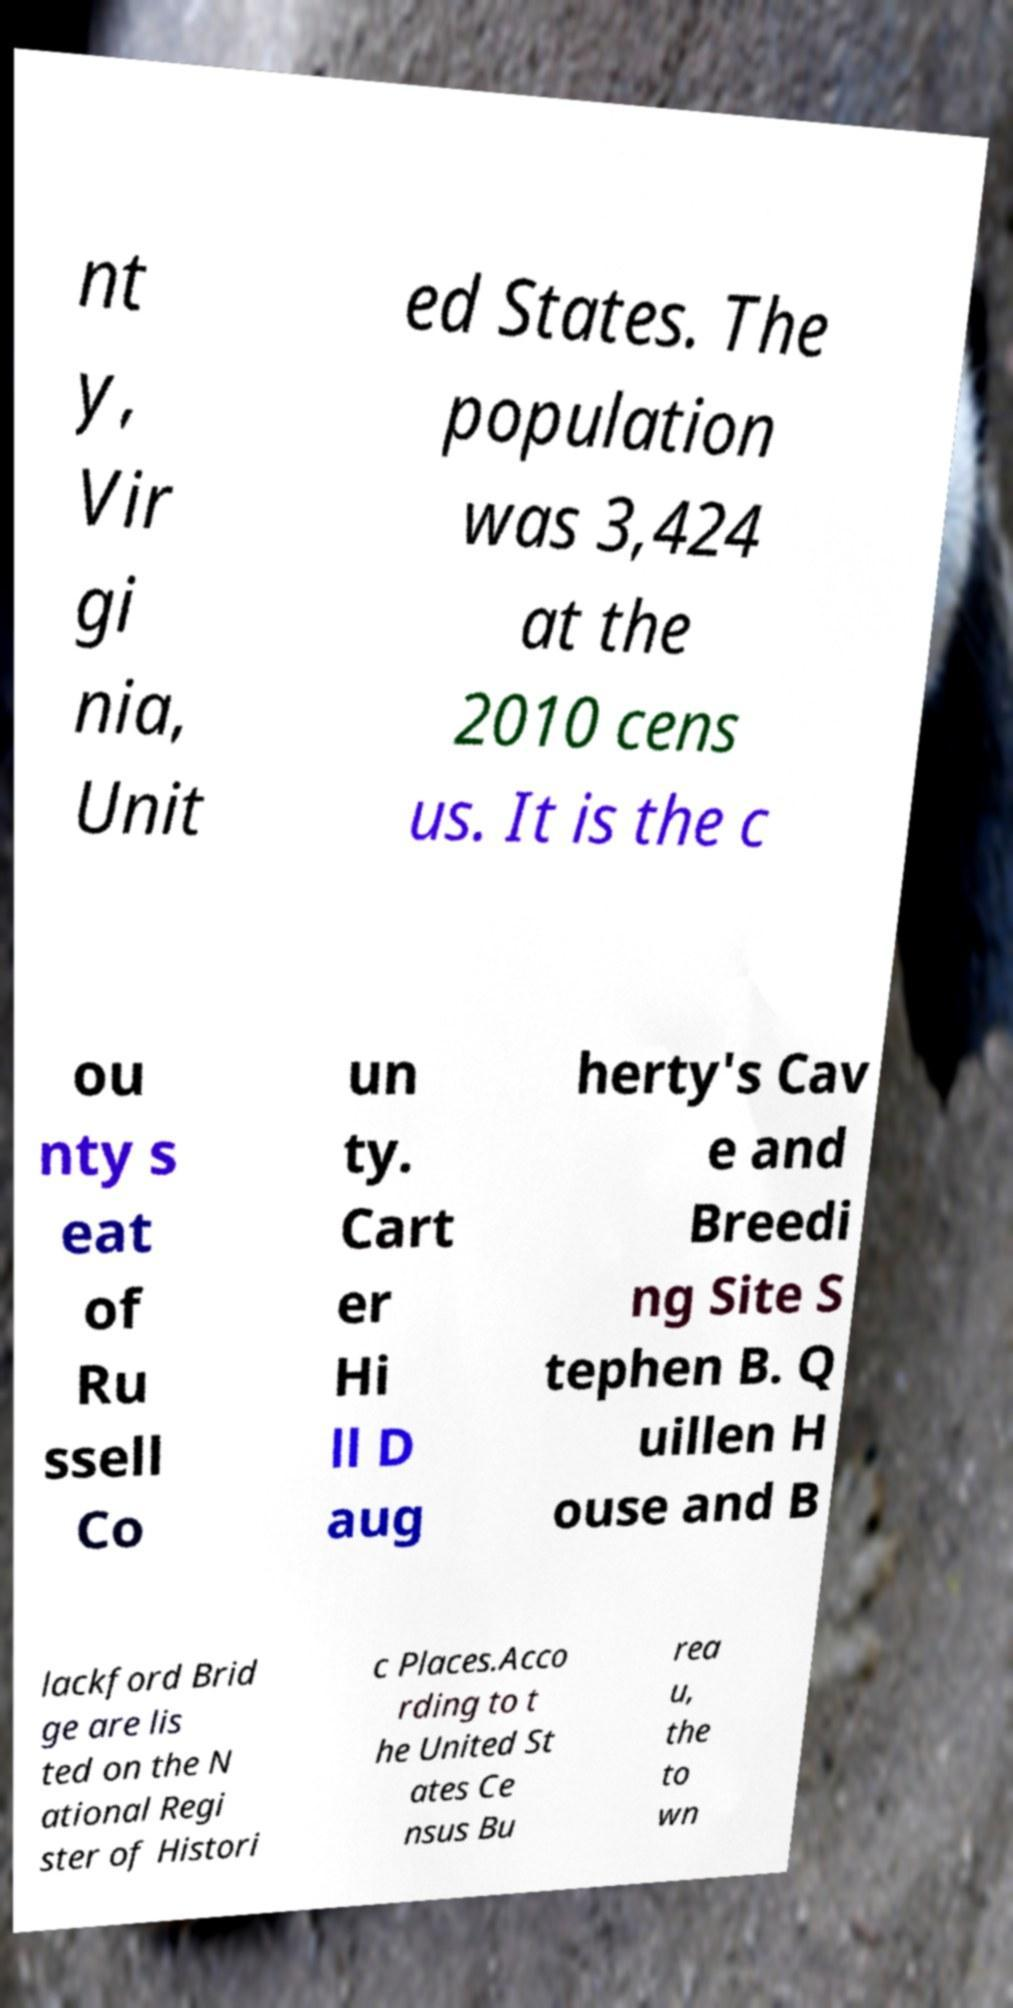Could you extract and type out the text from this image? nt y, Vir gi nia, Unit ed States. The population was 3,424 at the 2010 cens us. It is the c ou nty s eat of Ru ssell Co un ty. Cart er Hi ll D aug herty's Cav e and Breedi ng Site S tephen B. Q uillen H ouse and B lackford Brid ge are lis ted on the N ational Regi ster of Histori c Places.Acco rding to t he United St ates Ce nsus Bu rea u, the to wn 